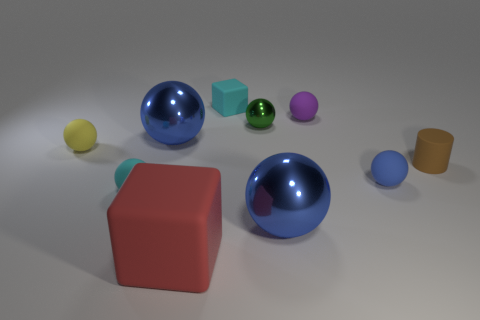Subtract all cyan balls. How many balls are left? 6 Subtract all red cubes. How many cubes are left? 1 Subtract 2 cubes. How many cubes are left? 0 Subtract all balls. How many objects are left? 3 Subtract all green spheres. Subtract all cyan blocks. How many spheres are left? 6 Subtract all brown cubes. How many red balls are left? 0 Subtract all small purple rubber spheres. Subtract all big purple shiny cylinders. How many objects are left? 9 Add 7 tiny cyan matte cubes. How many tiny cyan matte cubes are left? 8 Add 1 large blue metallic blocks. How many large blue metallic blocks exist? 1 Subtract 1 yellow spheres. How many objects are left? 9 